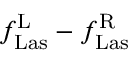<formula> <loc_0><loc_0><loc_500><loc_500>f _ { L a s } ^ { L } - f _ { L a s } ^ { R }</formula> 